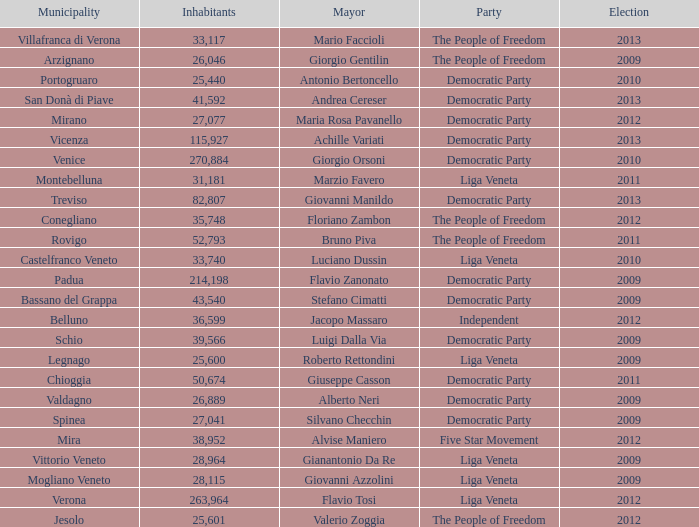In the election earlier than 2012 how many Inhabitants had a Party of five star movement? None. 